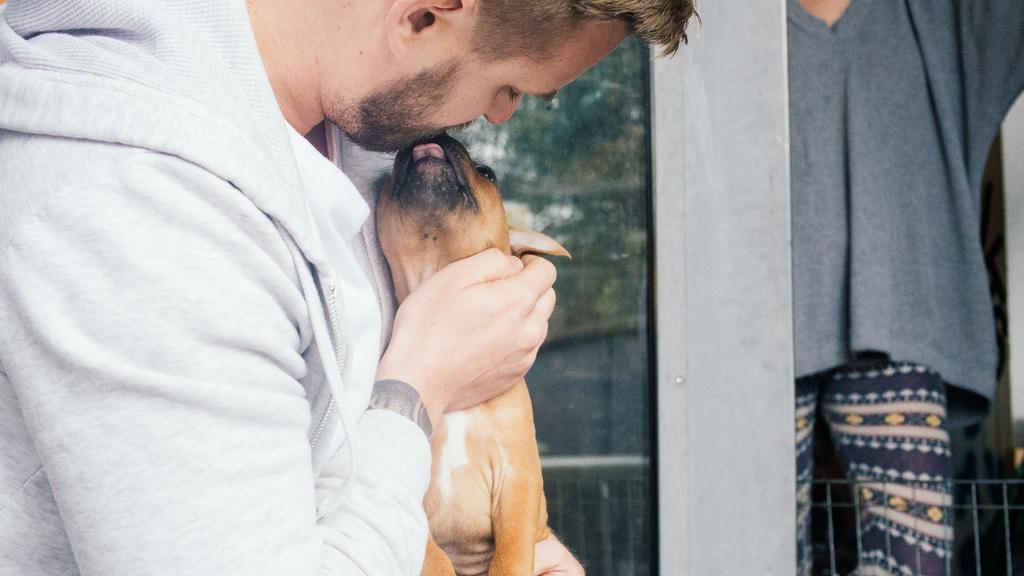Please provide a concise description of this image. In this image on the left there is a man he wear white jacket he is holding a dog. On the right there is a person. 